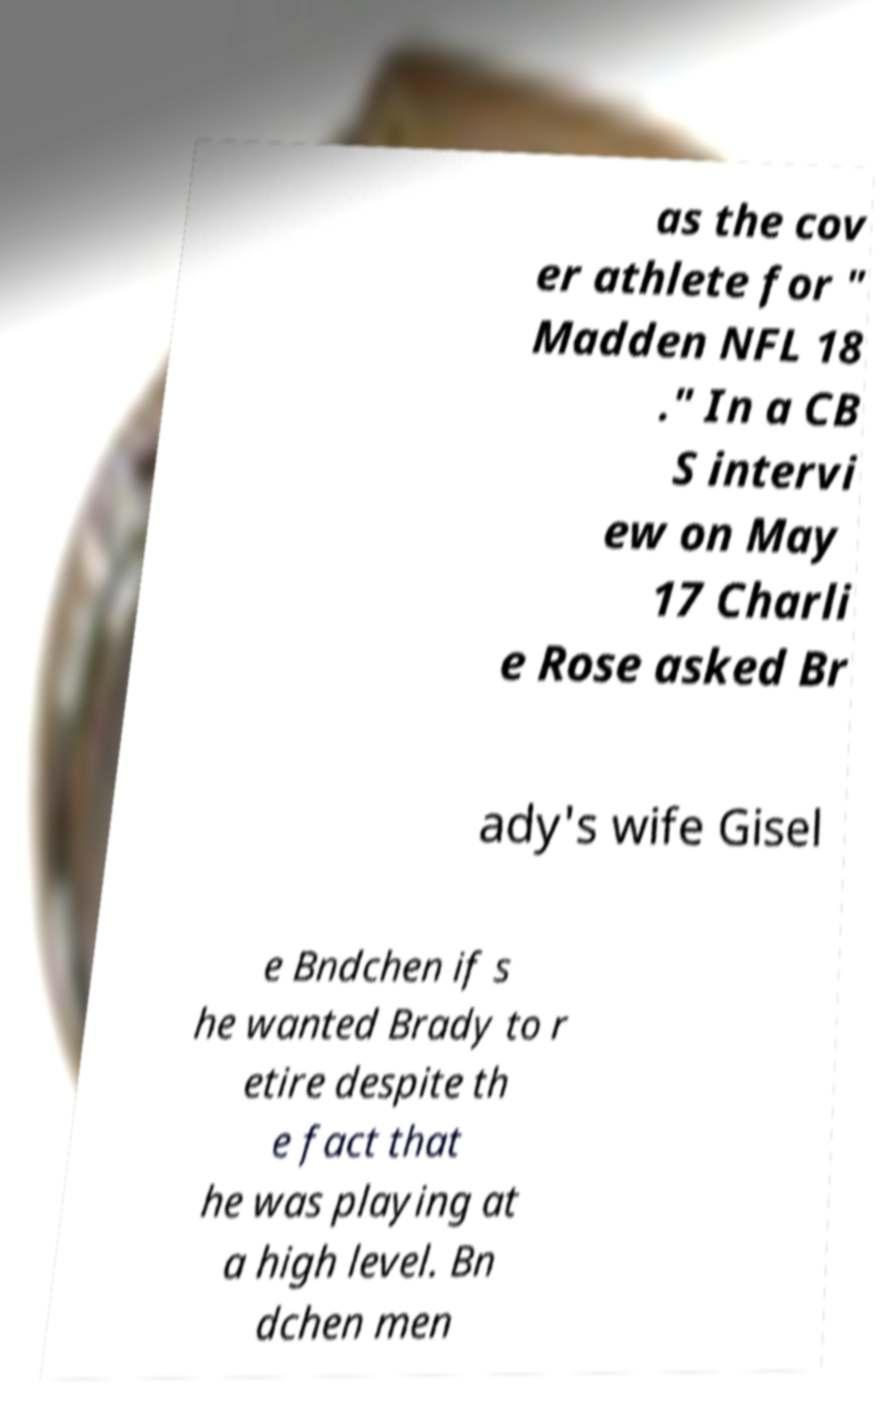Please read and relay the text visible in this image. What does it say? as the cov er athlete for " Madden NFL 18 ." In a CB S intervi ew on May 17 Charli e Rose asked Br ady's wife Gisel e Bndchen if s he wanted Brady to r etire despite th e fact that he was playing at a high level. Bn dchen men 